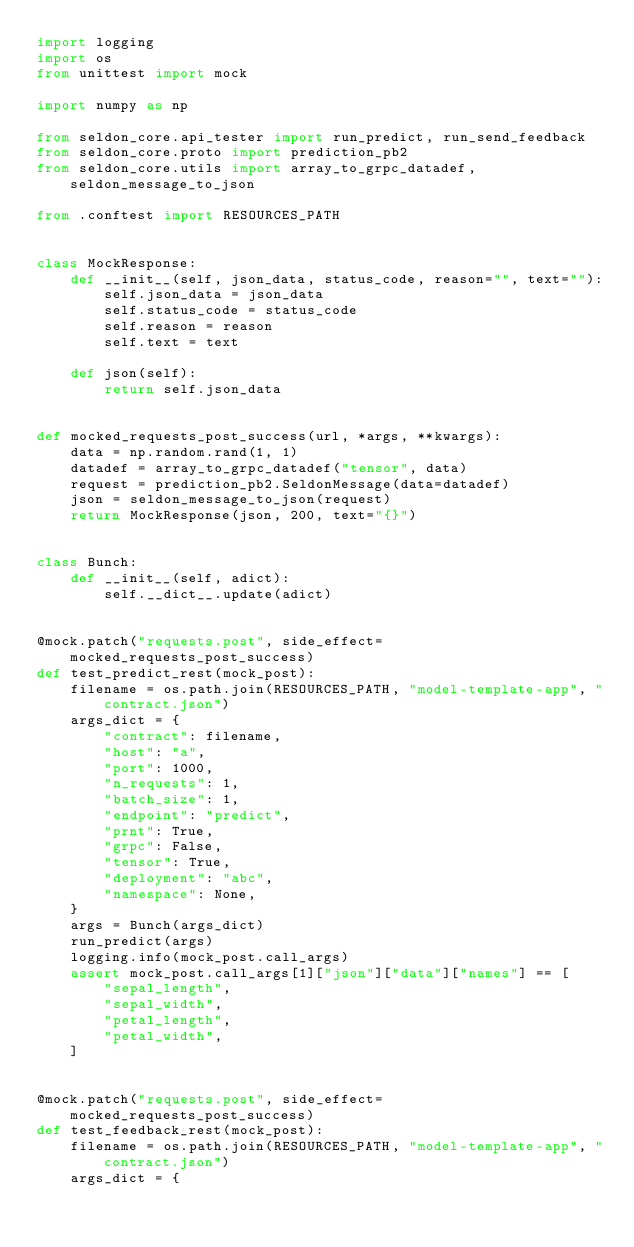Convert code to text. <code><loc_0><loc_0><loc_500><loc_500><_Python_>import logging
import os
from unittest import mock

import numpy as np

from seldon_core.api_tester import run_predict, run_send_feedback
from seldon_core.proto import prediction_pb2
from seldon_core.utils import array_to_grpc_datadef, seldon_message_to_json

from .conftest import RESOURCES_PATH


class MockResponse:
    def __init__(self, json_data, status_code, reason="", text=""):
        self.json_data = json_data
        self.status_code = status_code
        self.reason = reason
        self.text = text

    def json(self):
        return self.json_data


def mocked_requests_post_success(url, *args, **kwargs):
    data = np.random.rand(1, 1)
    datadef = array_to_grpc_datadef("tensor", data)
    request = prediction_pb2.SeldonMessage(data=datadef)
    json = seldon_message_to_json(request)
    return MockResponse(json, 200, text="{}")


class Bunch:
    def __init__(self, adict):
        self.__dict__.update(adict)


@mock.patch("requests.post", side_effect=mocked_requests_post_success)
def test_predict_rest(mock_post):
    filename = os.path.join(RESOURCES_PATH, "model-template-app", "contract.json")
    args_dict = {
        "contract": filename,
        "host": "a",
        "port": 1000,
        "n_requests": 1,
        "batch_size": 1,
        "endpoint": "predict",
        "prnt": True,
        "grpc": False,
        "tensor": True,
        "deployment": "abc",
        "namespace": None,
    }
    args = Bunch(args_dict)
    run_predict(args)
    logging.info(mock_post.call_args)
    assert mock_post.call_args[1]["json"]["data"]["names"] == [
        "sepal_length",
        "sepal_width",
        "petal_length",
        "petal_width",
    ]


@mock.patch("requests.post", side_effect=mocked_requests_post_success)
def test_feedback_rest(mock_post):
    filename = os.path.join(RESOURCES_PATH, "model-template-app", "contract.json")
    args_dict = {</code> 